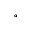Convert formula to latex. <formula><loc_0><loc_0><loc_500><loc_500>^ { \circ }</formula> 